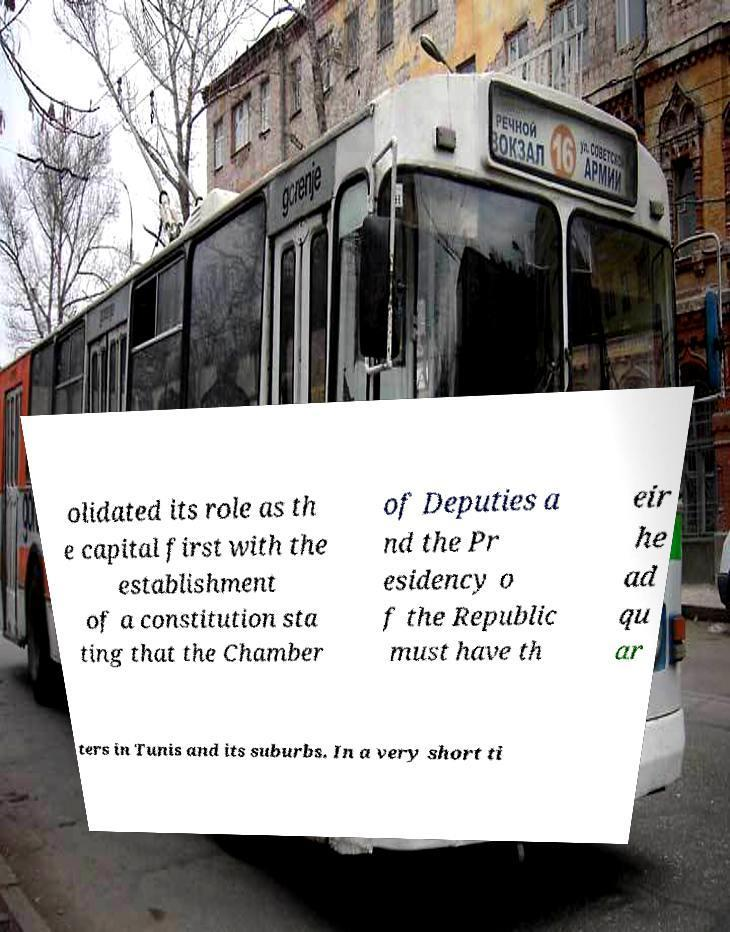Could you assist in decoding the text presented in this image and type it out clearly? olidated its role as th e capital first with the establishment of a constitution sta ting that the Chamber of Deputies a nd the Pr esidency o f the Republic must have th eir he ad qu ar ters in Tunis and its suburbs. In a very short ti 